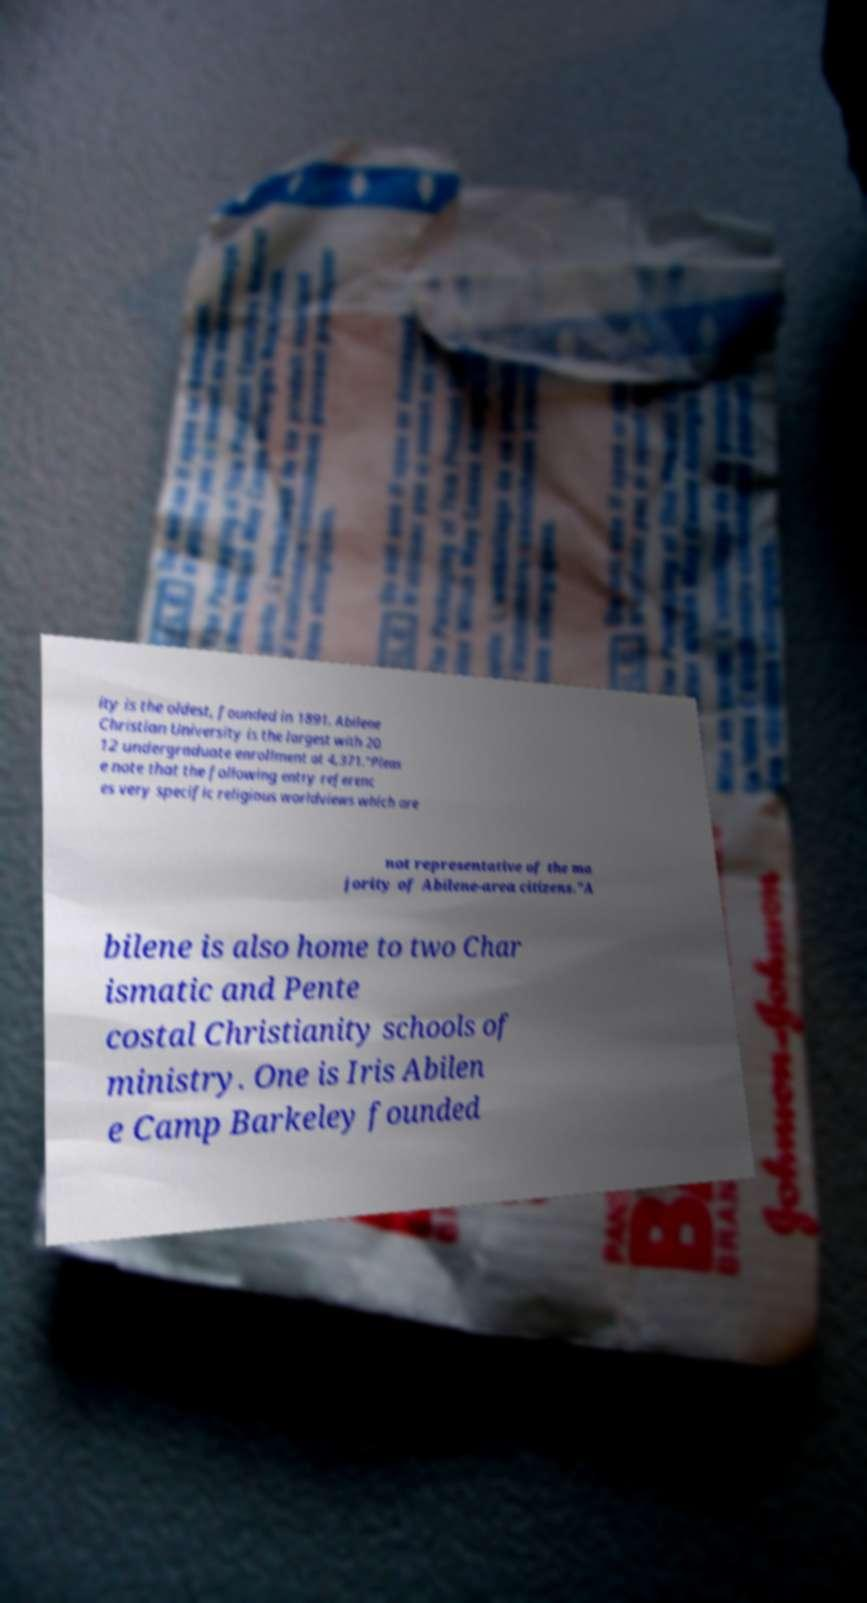Can you read and provide the text displayed in the image?This photo seems to have some interesting text. Can you extract and type it out for me? ity is the oldest, founded in 1891. Abilene Christian University is the largest with 20 12 undergraduate enrollment at 4,371."Pleas e note that the following entry referenc es very specific religious worldviews which are not representative of the ma jority of Abilene-area citizens."A bilene is also home to two Char ismatic and Pente costal Christianity schools of ministry. One is Iris Abilen e Camp Barkeley founded 